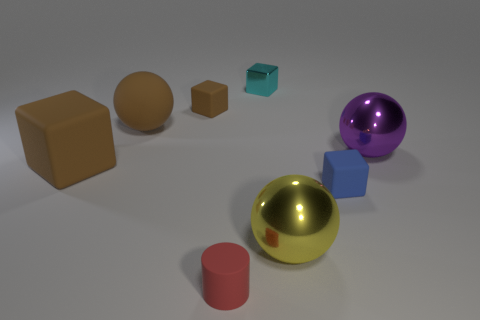Add 2 green matte blocks. How many objects exist? 10 Subtract all big rubber cubes. How many cubes are left? 3 Subtract all brown spheres. How many spheres are left? 2 Add 8 big shiny objects. How many big shiny objects are left? 10 Add 2 tiny metal things. How many tiny metal things exist? 3 Subtract 0 brown cylinders. How many objects are left? 8 Subtract all cylinders. How many objects are left? 7 Subtract 3 balls. How many balls are left? 0 Subtract all gray blocks. Subtract all yellow spheres. How many blocks are left? 4 Subtract all yellow cylinders. How many gray blocks are left? 0 